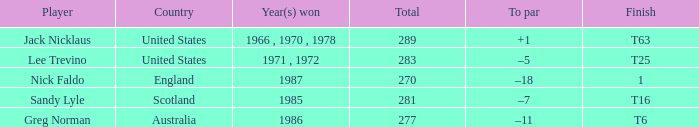What player has 1 as the place? Nick Faldo. 